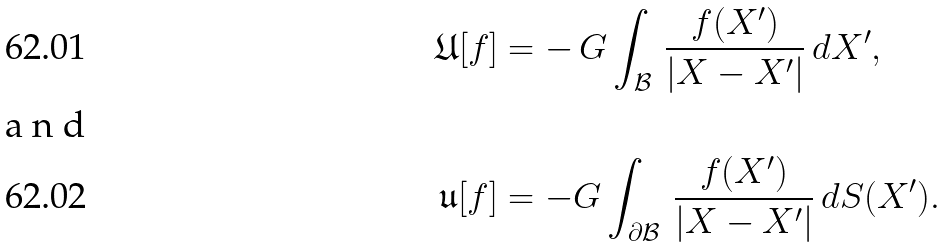Convert formula to latex. <formula><loc_0><loc_0><loc_500><loc_500>\mathfrak { U } [ f ] & = - \, G \int _ { \mathcal { B } } \, \frac { f ( X ^ { \prime } ) } { | X - X ^ { \prime } | } \, d X ^ { \prime } , \\ \intertext { a n d } \mathfrak { u } [ f ] & = - G \int _ { \partial \mathcal { B } } \, \frac { f ( X ^ { \prime } ) } { | X - X ^ { \prime } | } \, d S ( X ^ { \prime } ) .</formula> 